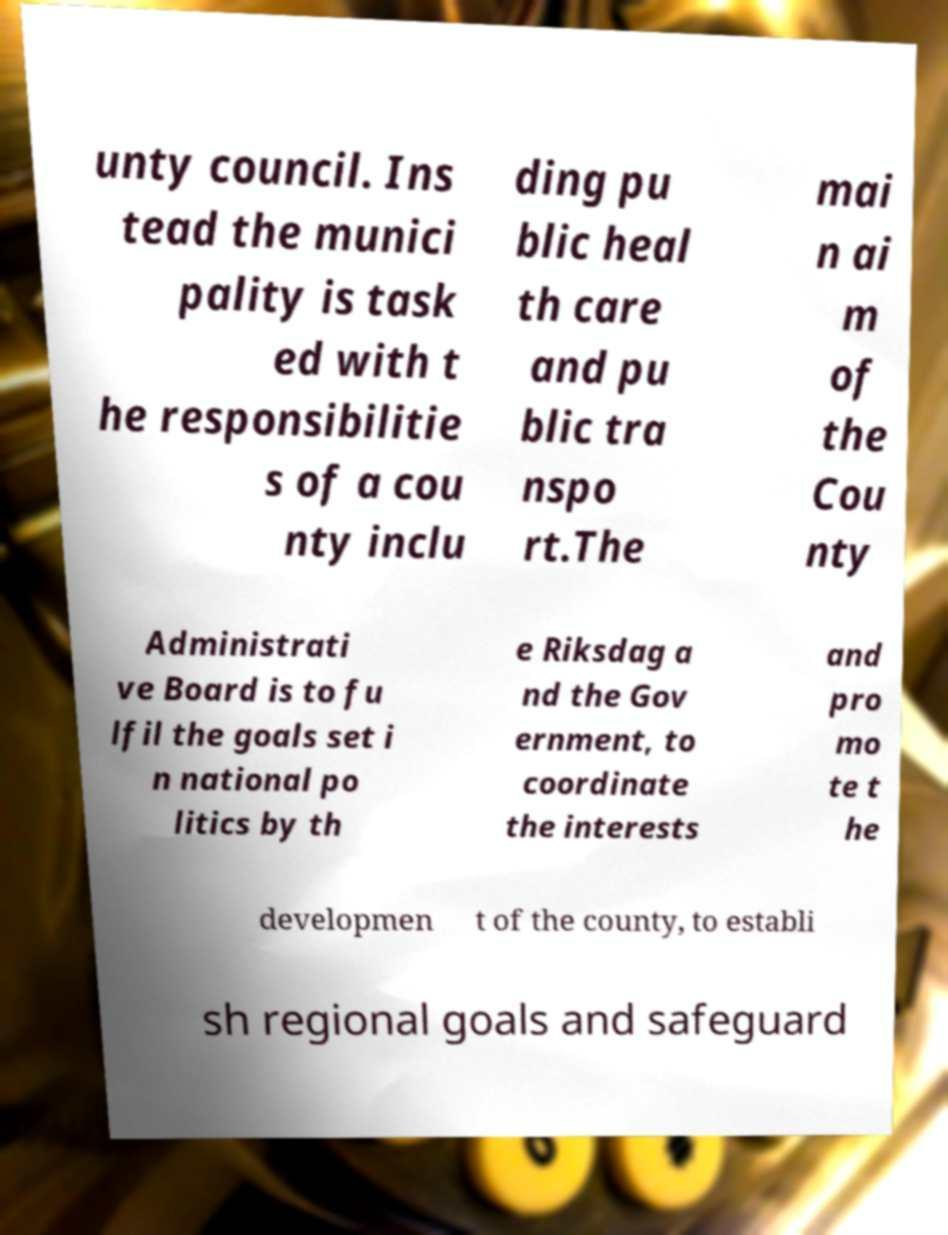Please identify and transcribe the text found in this image. unty council. Ins tead the munici pality is task ed with t he responsibilitie s of a cou nty inclu ding pu blic heal th care and pu blic tra nspo rt.The mai n ai m of the Cou nty Administrati ve Board is to fu lfil the goals set i n national po litics by th e Riksdag a nd the Gov ernment, to coordinate the interests and pro mo te t he developmen t of the county, to establi sh regional goals and safeguard 